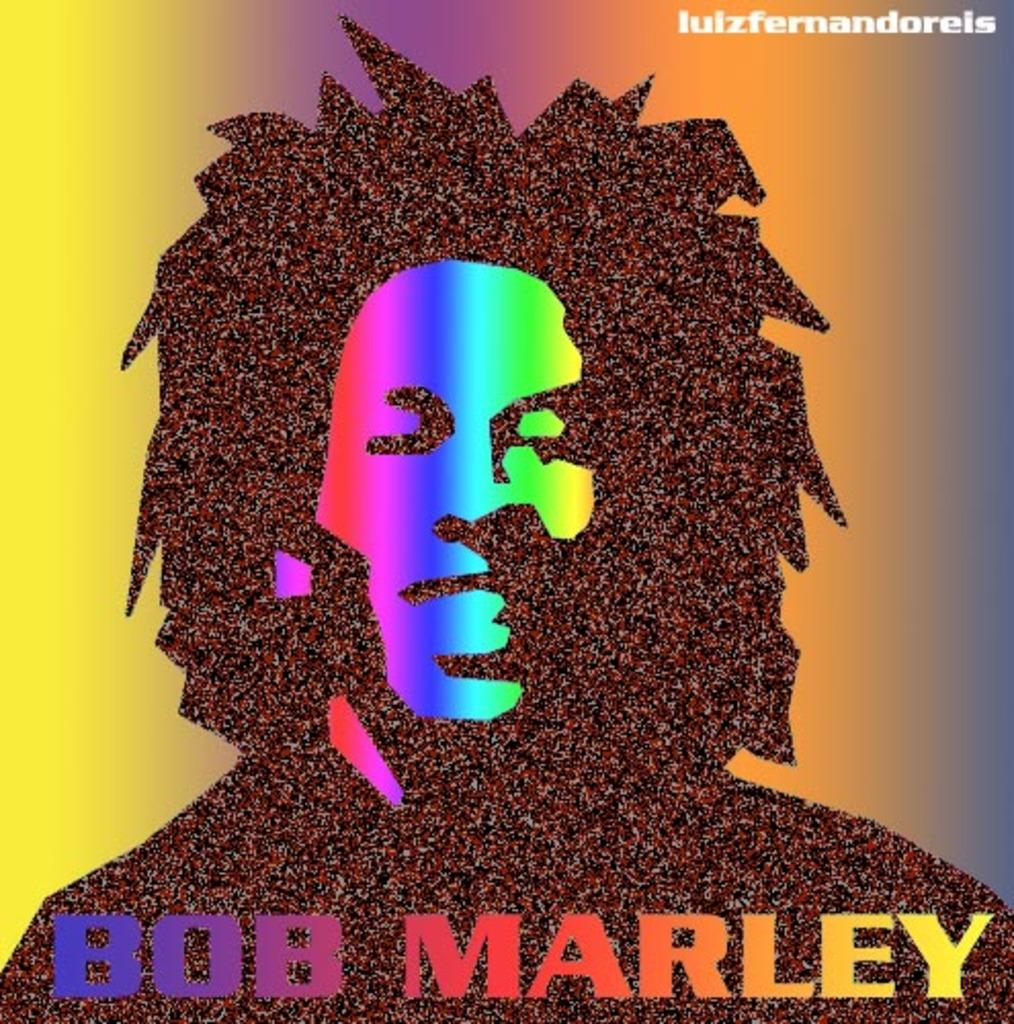<image>
Share a concise interpretation of the image provided. a Bob Marley photo with his name appearing very colorful 